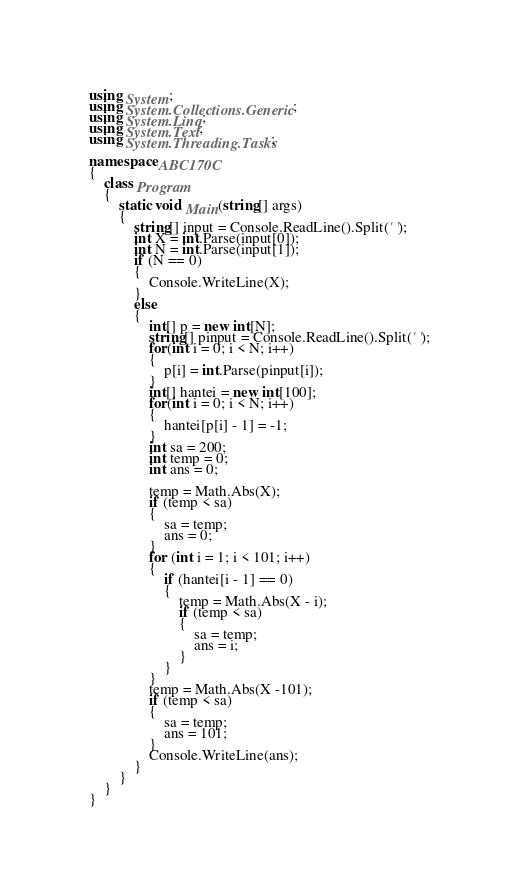Convert code to text. <code><loc_0><loc_0><loc_500><loc_500><_C#_>using System;
using System.Collections.Generic;
using System.Linq;
using System.Text;
using System.Threading.Tasks;

namespace ABC170C
{
    class Program
    {
        static void Main(string[] args)
        {
            string[] input = Console.ReadLine().Split(' ');
            int X = int.Parse(input[0]);
            int N = int.Parse(input[1]);
            if (N == 0)
            {
                Console.WriteLine(X);
            }
            else
            {
                int[] p = new int[N];
                string[] pinput = Console.ReadLine().Split(' ');
                for(int i = 0; i < N; i++)
                {
                    p[i] = int.Parse(pinput[i]);
                }
                int[] hantei = new int[100];
                for(int i = 0; i < N; i++)
                {
                    hantei[p[i] - 1] = -1;
                }
                int sa = 200;
                int temp = 0;
                int ans = 0;

                temp = Math.Abs(X);
                if (temp < sa)
                {
                    sa = temp;
                    ans = 0;
                }
                for (int i = 1; i < 101; i++)
                {
                    if (hantei[i - 1] == 0)
                    {
                        temp = Math.Abs(X - i);
                        if (temp < sa)
                        {
                            sa = temp;
                            ans = i;
                        }
                    }
                }
                temp = Math.Abs(X -101);
                if (temp < sa)
                {
                    sa = temp;
                    ans = 101;
                }
                Console.WriteLine(ans);
            }
        }
    }
}
</code> 